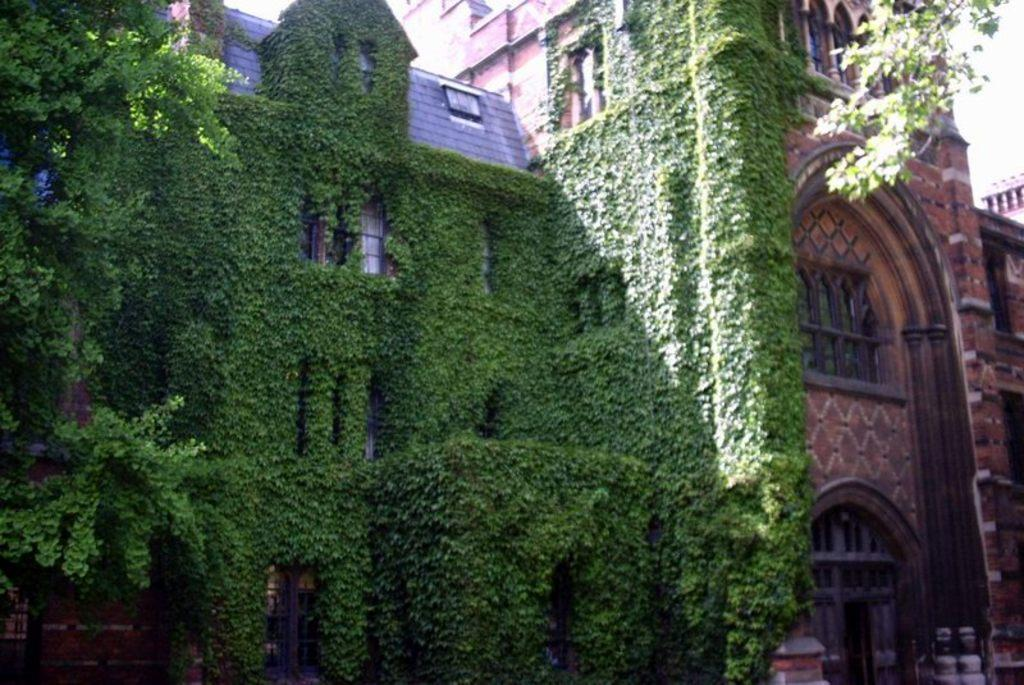What type of structure is visible in the image? There is a building in the image. What feature of the building can be observed? The building has multiple windows. What is covering the building in the image? The building is covered with plants. What type of vegetation is present in the image? There are trees present in the image. What type of jewel is being served for dinner on the sofa in the image? There is no reference to a jewel, dinner, or sofa in the image; it features a building covered with plants and surrounded by trees. 